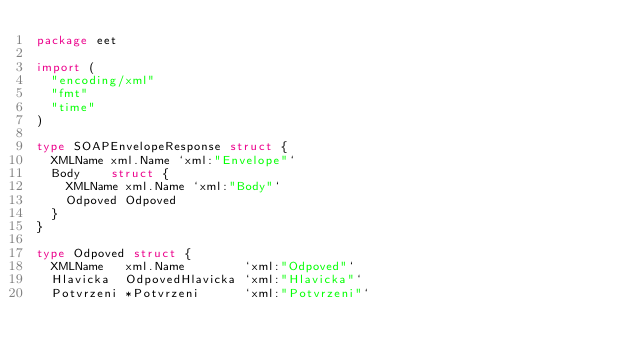Convert code to text. <code><loc_0><loc_0><loc_500><loc_500><_Go_>package eet

import (
	"encoding/xml"
	"fmt"
	"time"
)

type SOAPEnvelopeResponse struct {
	XMLName xml.Name `xml:"Envelope"`
	Body    struct {
		XMLName xml.Name `xml:"Body"`
		Odpoved Odpoved
	}
}

type Odpoved struct {
	XMLName   xml.Name        `xml:"Odpoved"`
	Hlavicka  OdpovedHlavicka `xml:"Hlavicka"`
	Potvrzeni *Potvrzeni      `xml:"Potvrzeni"`</code> 